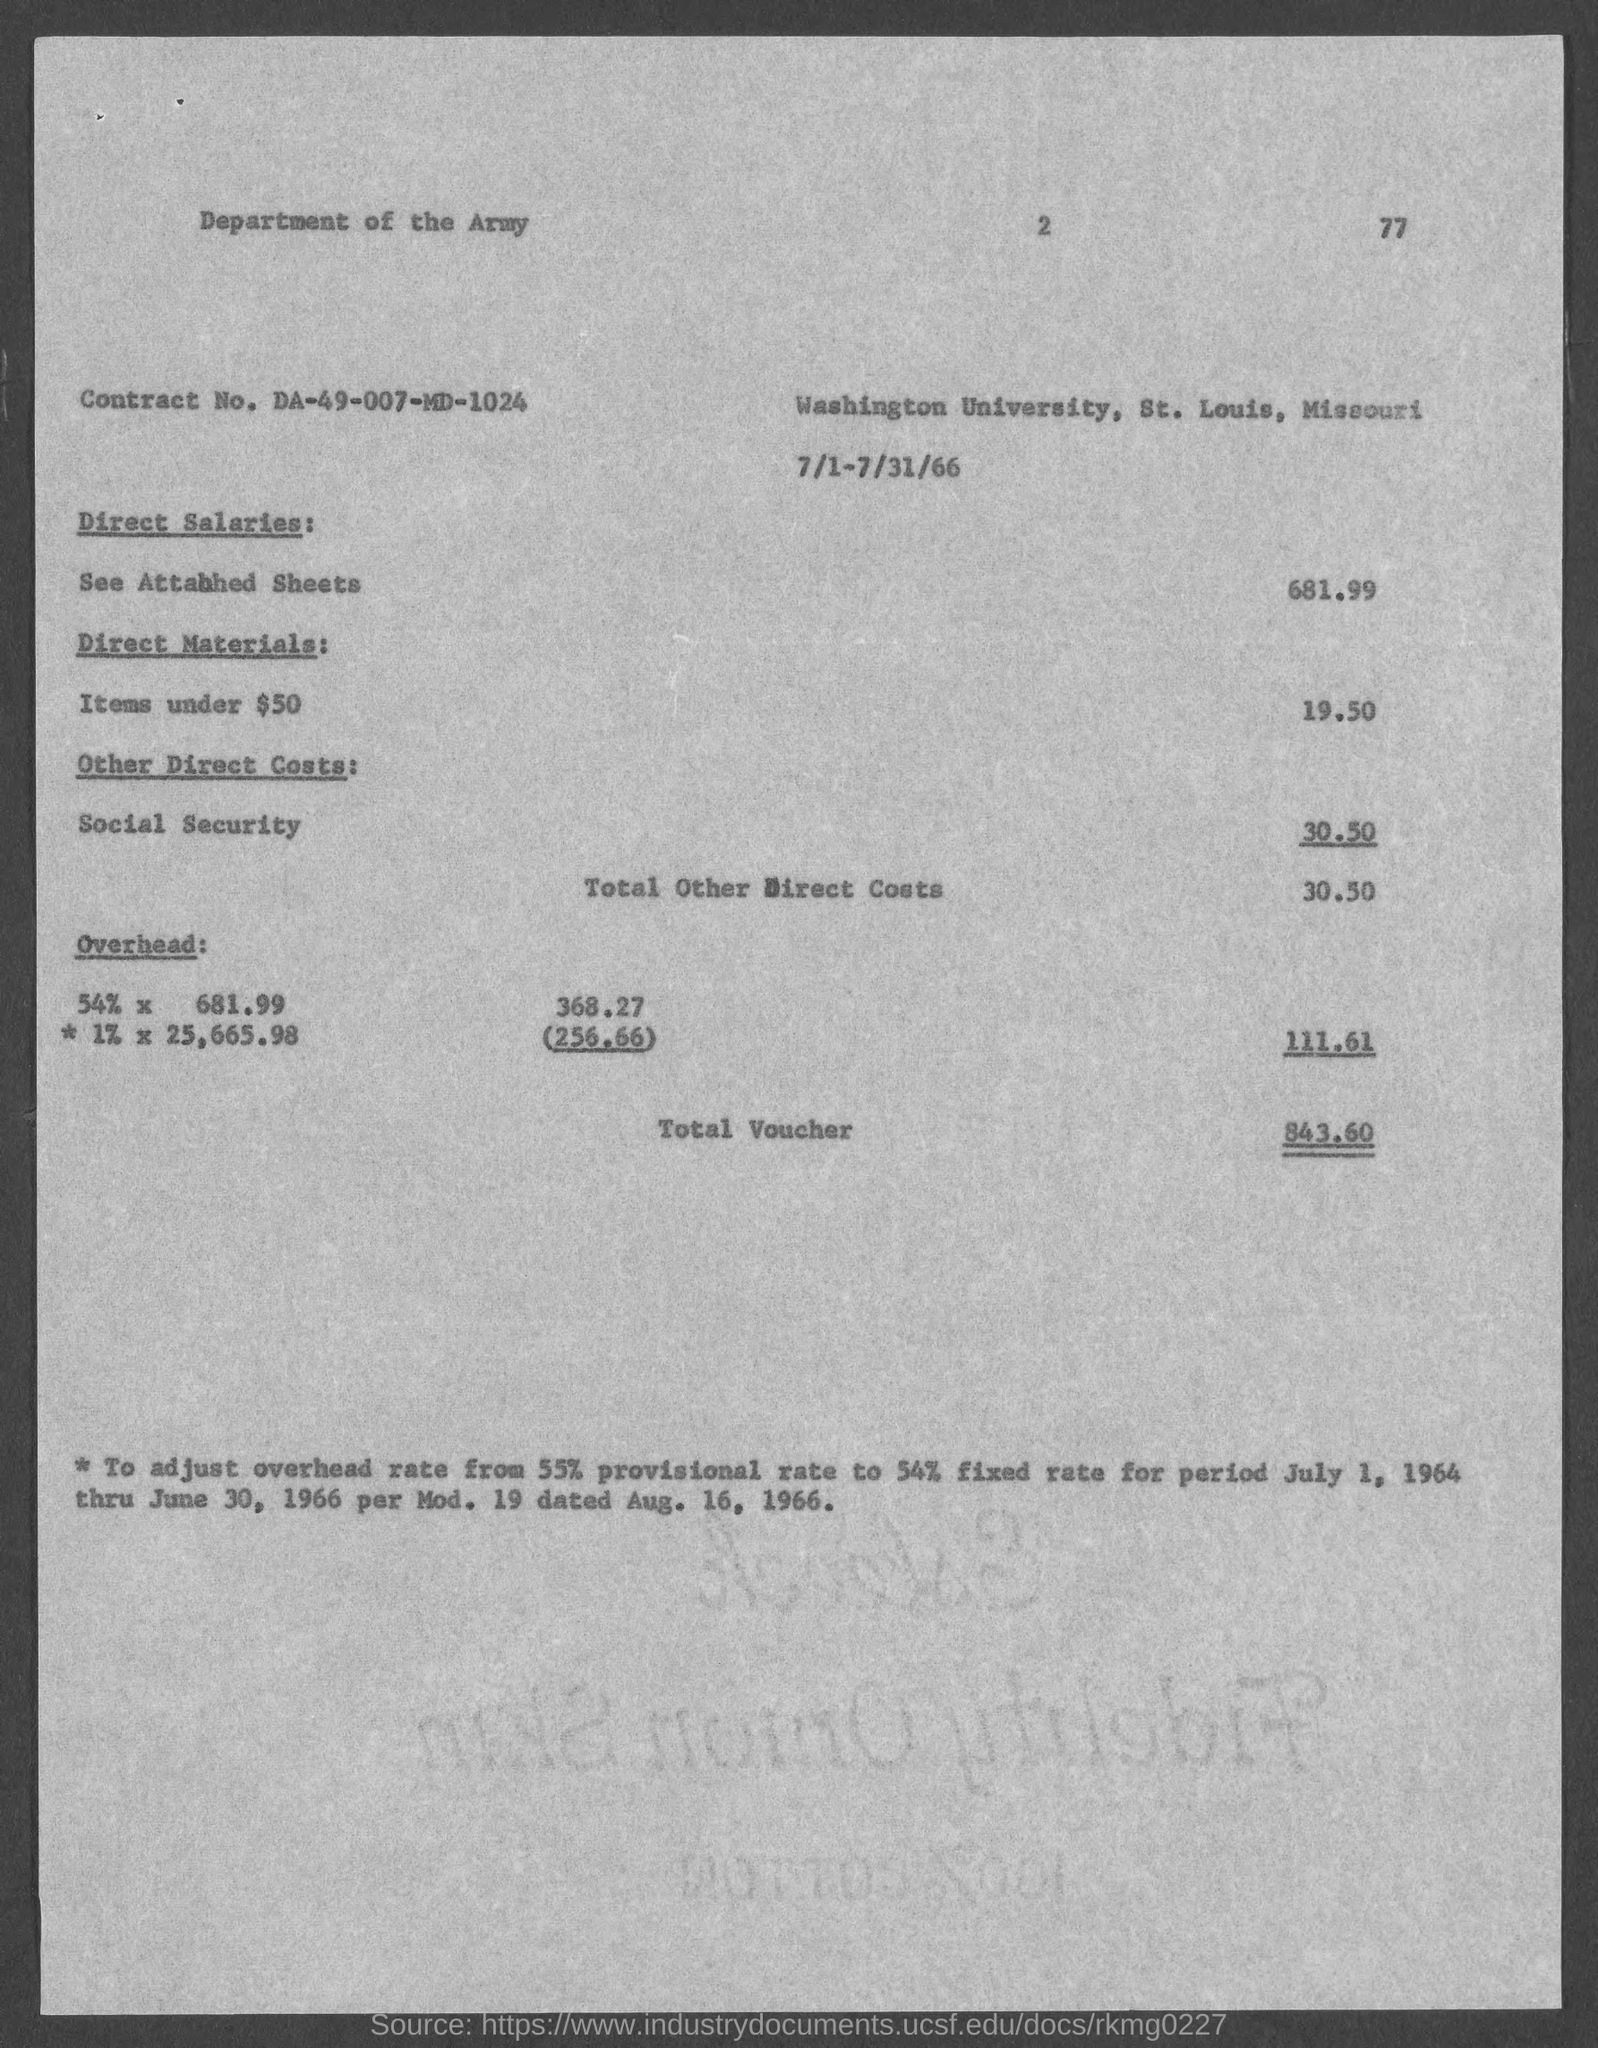What is the contract no.?
Offer a very short reply. DA-49-007-MD-1024. What is the total voucher amount ?
Offer a terse response. 843.60. 